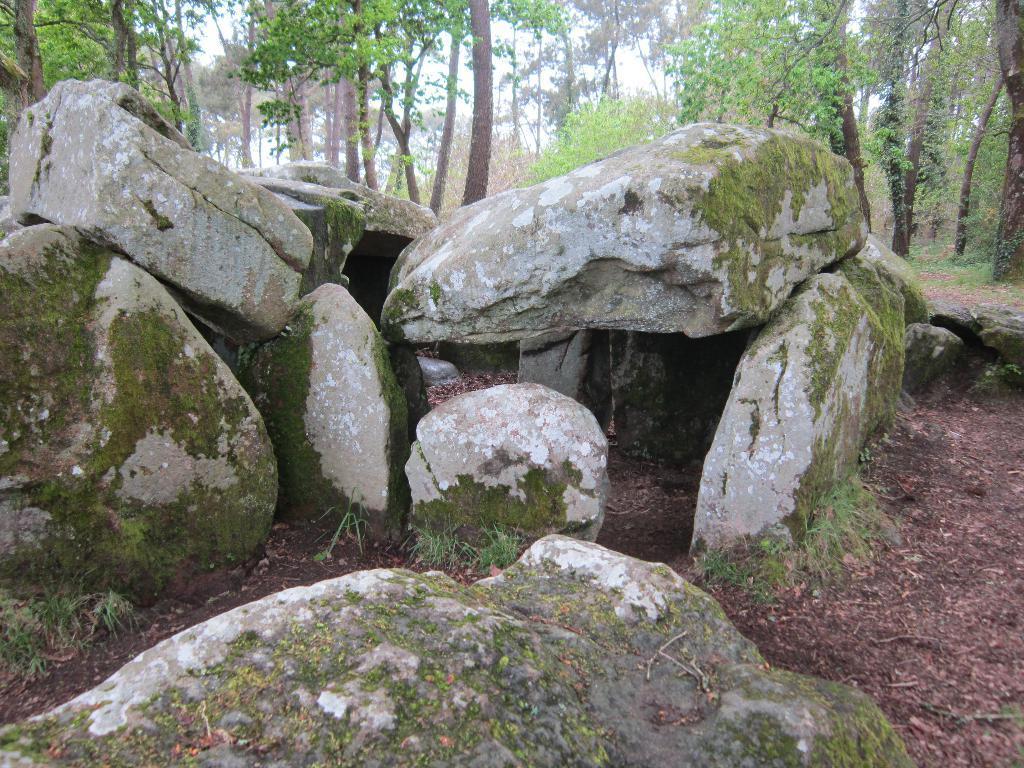Can you describe this image briefly? As we can see in the image, there are lot of rocks in the front and in the background there are lot of trees. 